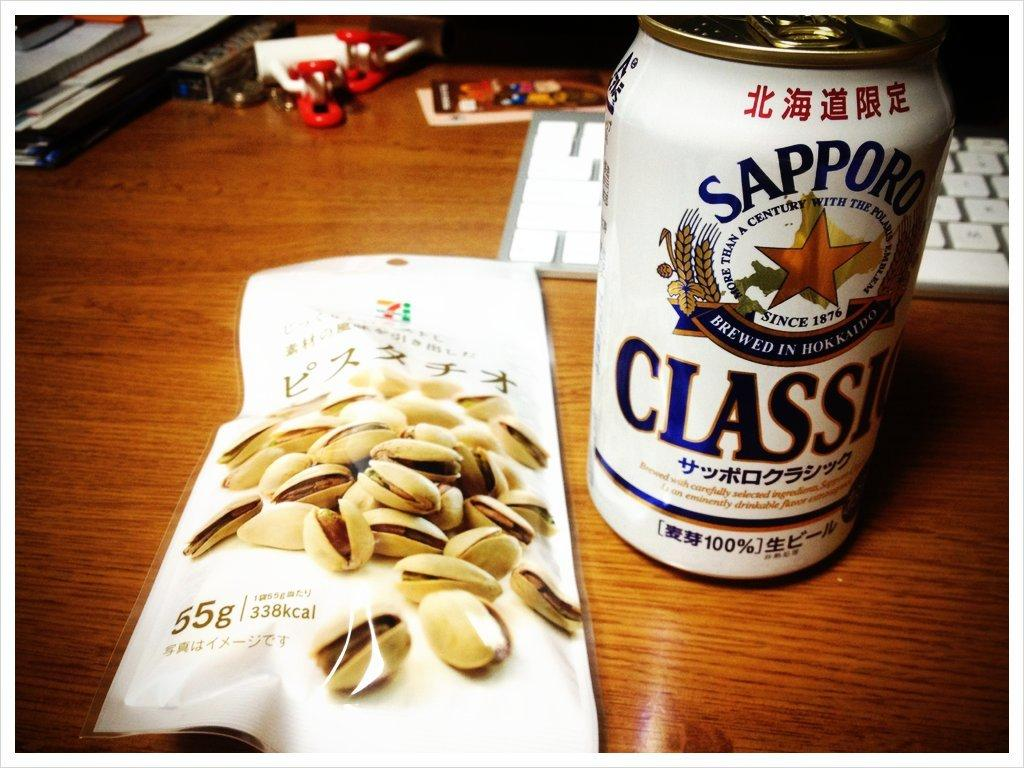What is one of the objects visible in the image? There is a packet in the image. What is another object visible in the image? There is a tin in the image. What is the third object visible in the image? There is a keyboard in the image. Can you describe the surface where the objects are placed? There are other objects on a wooden platform in the image. What type of fowl can be seen sitting on the keyboard in the image? There is no fowl present in the image, and the keyboard is not being used by any animal. 